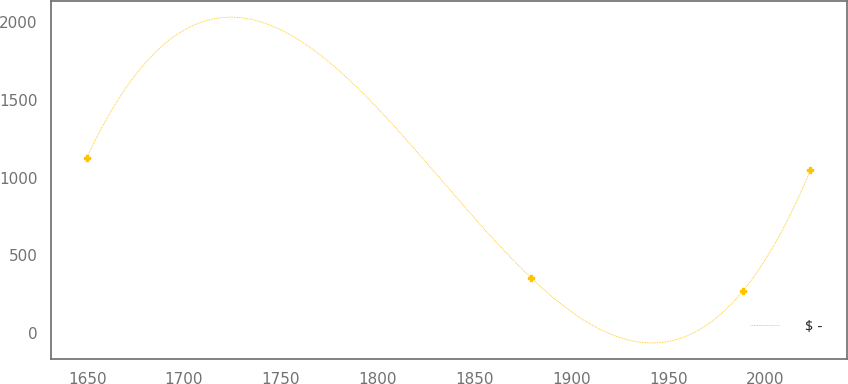<chart> <loc_0><loc_0><loc_500><loc_500><line_chart><ecel><fcel>$ -<nl><fcel>1649.75<fcel>1129.79<nl><fcel>1879.38<fcel>353.88<nl><fcel>1988.54<fcel>271.78<nl><fcel>2023.34<fcel>1047.69<nl></chart> 